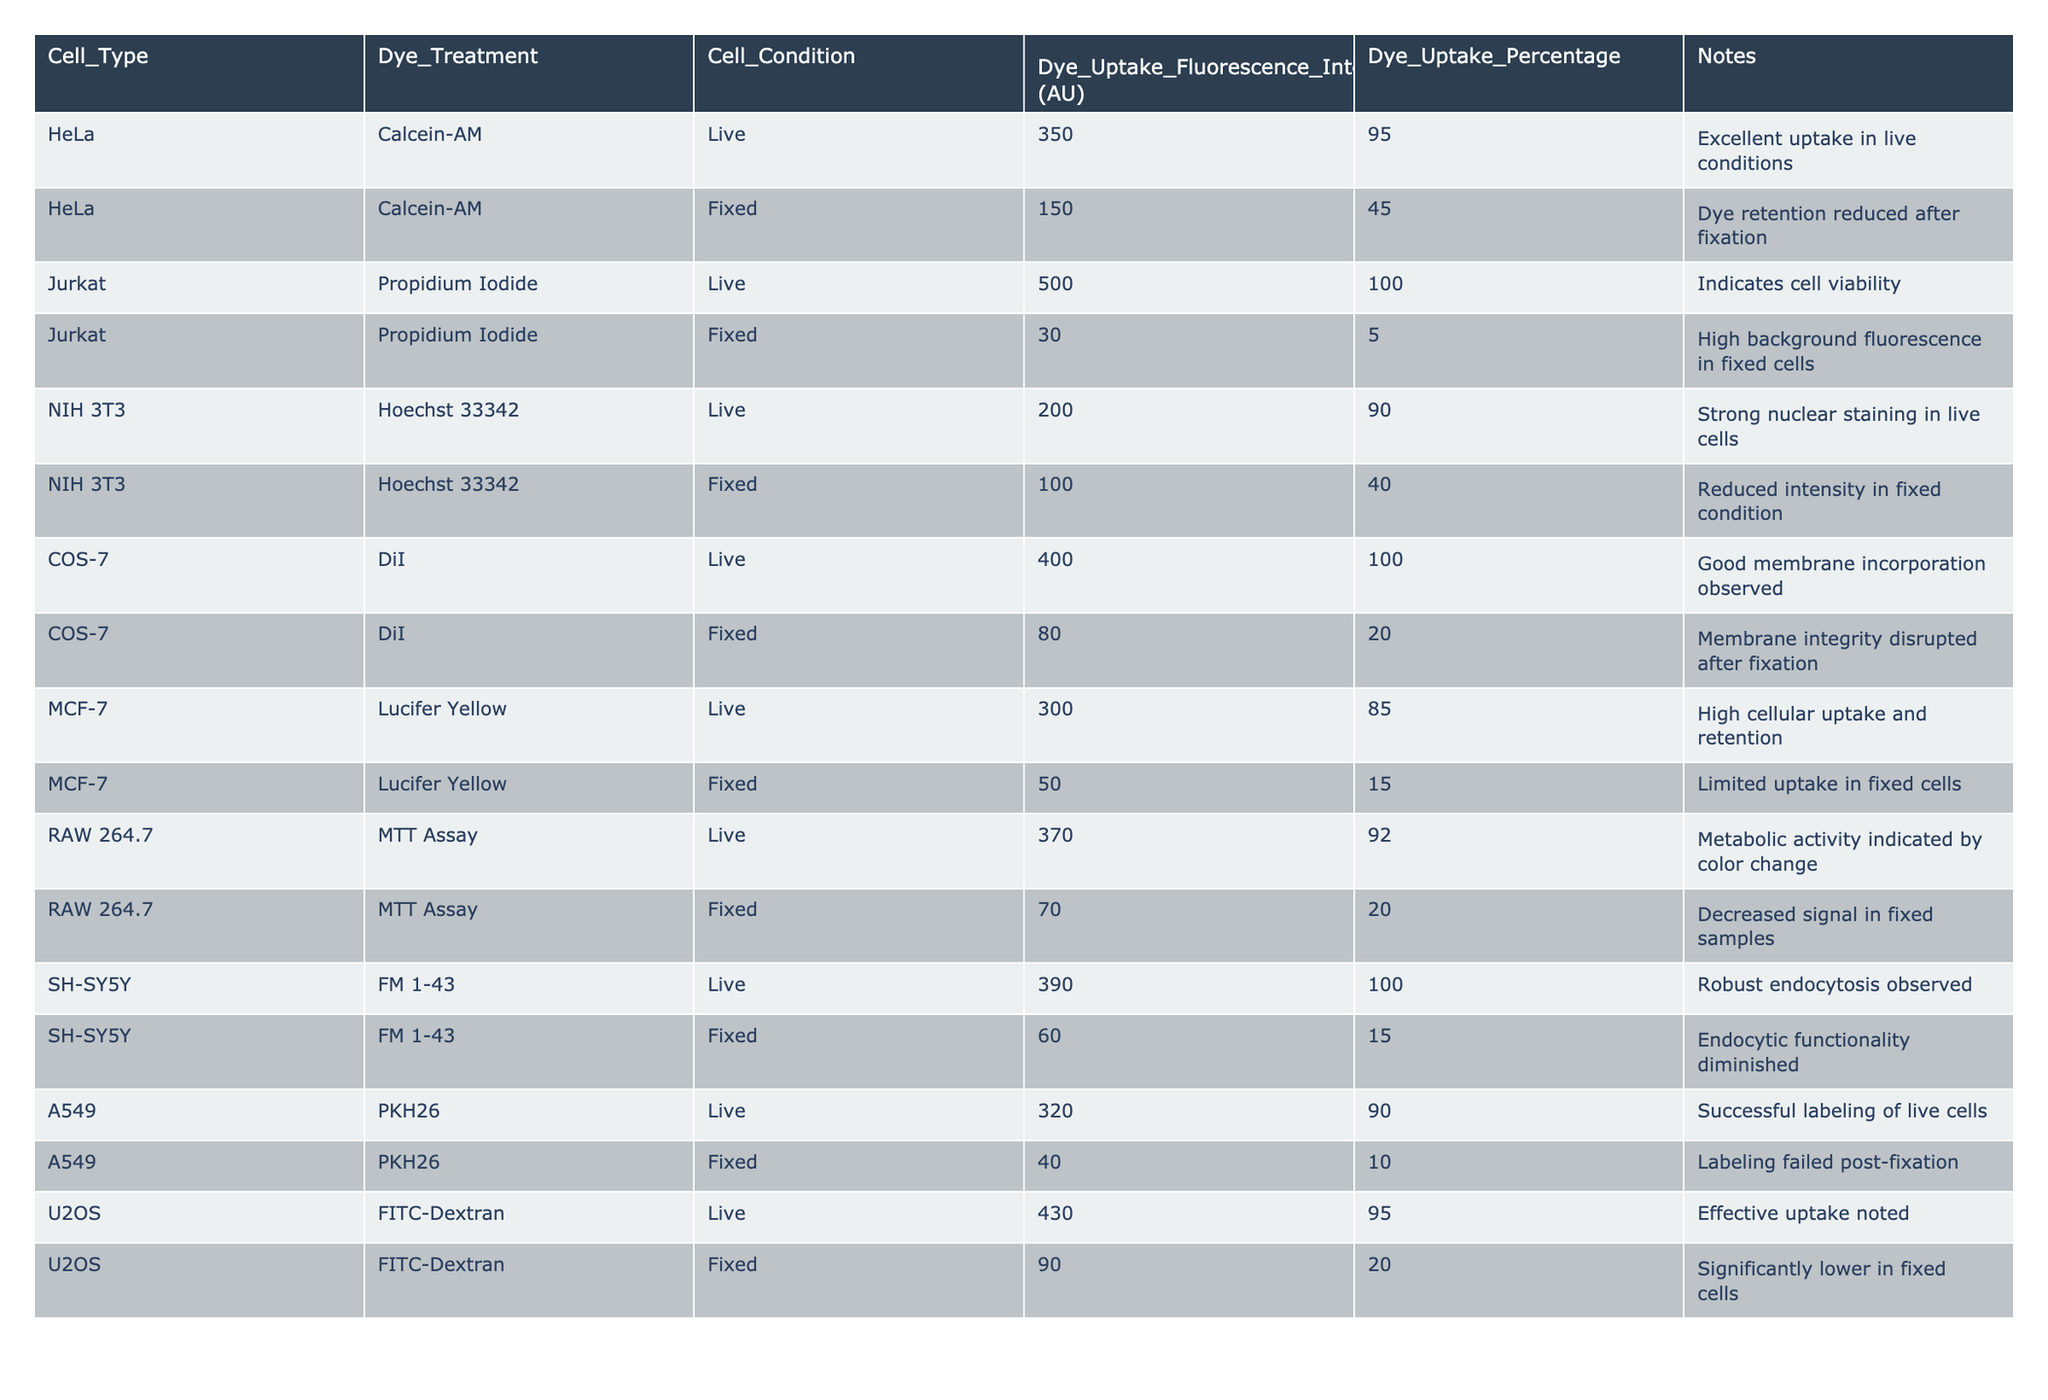What is the dye uptake percentage for live Jurkat cells treated with Propidium Iodide? From the table, the dye uptake percentage for live Jurkat cells treated with Propidium Iodide is directly listed as 100%.
Answer: 100% What is the fluorescence intensity for fixed COS-7 cells treated with DiI? The table shows that the fluorescence intensity for fixed COS-7 cells treated with DiI is 80 AU.
Answer: 80 AU Which cell type showed the highest fluorescence intensity for fixed cells? Comparing the values in the "Dye Uptake Fluorescence Intensity" column for fixed cells, RAW 264.7 showed the highest intensity at 70 AU.
Answer: RAW 264.7 What is the average dye uptake percentage in fixed cells across all cell types? The dye uptake percentages for fixed cells are 45, 5, 40, 20, 15, 20, 10, and 20, totaling 165. Dividing by the number of cell types (8) gives an average of 20.625%.
Answer: 20.63% Did any live cells show less dye uptake percentage than fixed cells? By checking each cell type, all live cells had a higher percentage uptake compared to their fixed counterparts. Thus, the answer is no.
Answer: No Which dye had the lowest uptake in fixed conditions and what was the percentage? Reviewing the fixed conditions, Propidium Iodide for Jurkat cells had a dye uptake percentage of only 5%, the lowest among all dyes in fixed conditions.
Answer: Propidium Iodide, 5% How much does the dye uptake fluorescence intensity decrease on average from live to fixed conditions across all cell types? The fluorescent intensity values for live and fixed conditions are: 350-150, 500-30, 200-100, 400-80, 300-50, 370-70, 390-60, 320-40. The total decrease is 200 + 470 + 100 + 320 + 250 + 300 + 330 + 280 = 2240. The average decrease is 2240/8 = 280 AU.
Answer: 280 AU Which cell type had the greatest reduction in dye uptake after fixation? By examining the percentage decreases, Jurkat cells with Propidium Iodide demonstrated a reduction from 100% to 5%, thus a loss of 95%.
Answer: Jurkat cells with Propidium Iodide What can be concluded about the integrity of membrane labeling in fixed cells for COS-7? The table indicates that membrane integrity for COS-7 cells was disrupted after fixation, leading to a dye uptake percentage of only 20%.
Answer: Membrane integrity is compromised 